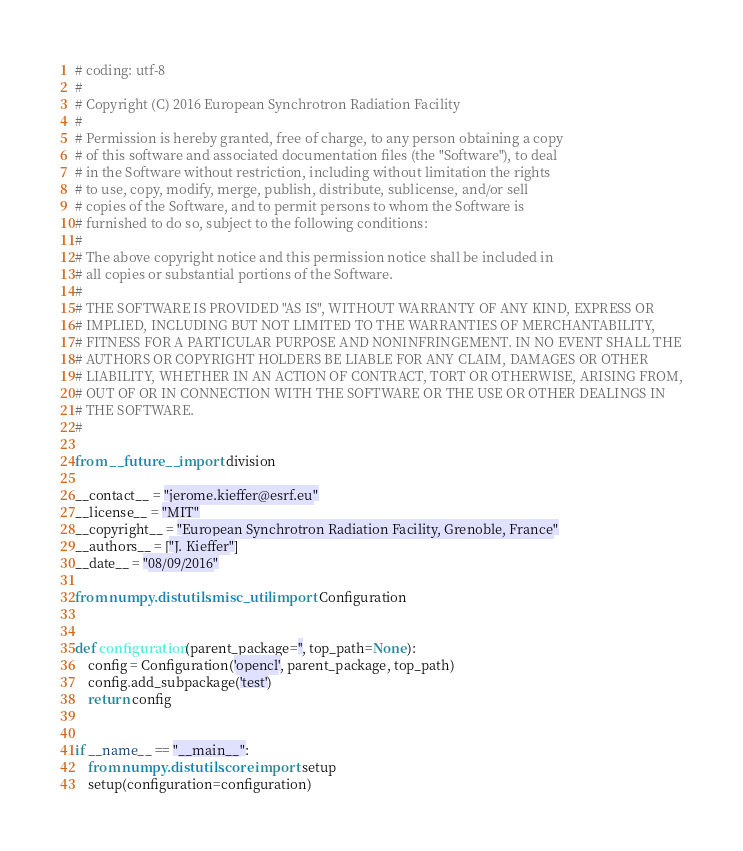<code> <loc_0><loc_0><loc_500><loc_500><_Python_># coding: utf-8
#
# Copyright (C) 2016 European Synchrotron Radiation Facility
#
# Permission is hereby granted, free of charge, to any person obtaining a copy
# of this software and associated documentation files (the "Software"), to deal
# in the Software without restriction, including without limitation the rights
# to use, copy, modify, merge, publish, distribute, sublicense, and/or sell
# copies of the Software, and to permit persons to whom the Software is
# furnished to do so, subject to the following conditions:
#
# The above copyright notice and this permission notice shall be included in
# all copies or substantial portions of the Software.
#
# THE SOFTWARE IS PROVIDED "AS IS", WITHOUT WARRANTY OF ANY KIND, EXPRESS OR
# IMPLIED, INCLUDING BUT NOT LIMITED TO THE WARRANTIES OF MERCHANTABILITY,
# FITNESS FOR A PARTICULAR PURPOSE AND NONINFRINGEMENT. IN NO EVENT SHALL THE
# AUTHORS OR COPYRIGHT HOLDERS BE LIABLE FOR ANY CLAIM, DAMAGES OR OTHER
# LIABILITY, WHETHER IN AN ACTION OF CONTRACT, TORT OR OTHERWISE, ARISING FROM,
# OUT OF OR IN CONNECTION WITH THE SOFTWARE OR THE USE OR OTHER DEALINGS IN
# THE SOFTWARE.
#

from __future__ import division

__contact__ = "jerome.kieffer@esrf.eu"
__license__ = "MIT"
__copyright__ = "European Synchrotron Radiation Facility, Grenoble, France"
__authors__ = ["J. Kieffer"]
__date__ = "08/09/2016"

from numpy.distutils.misc_util import Configuration


def configuration(parent_package='', top_path=None):
    config = Configuration('opencl', parent_package, top_path)
    config.add_subpackage('test')
    return config


if __name__ == "__main__":
    from numpy.distutils.core import setup
    setup(configuration=configuration)
</code> 